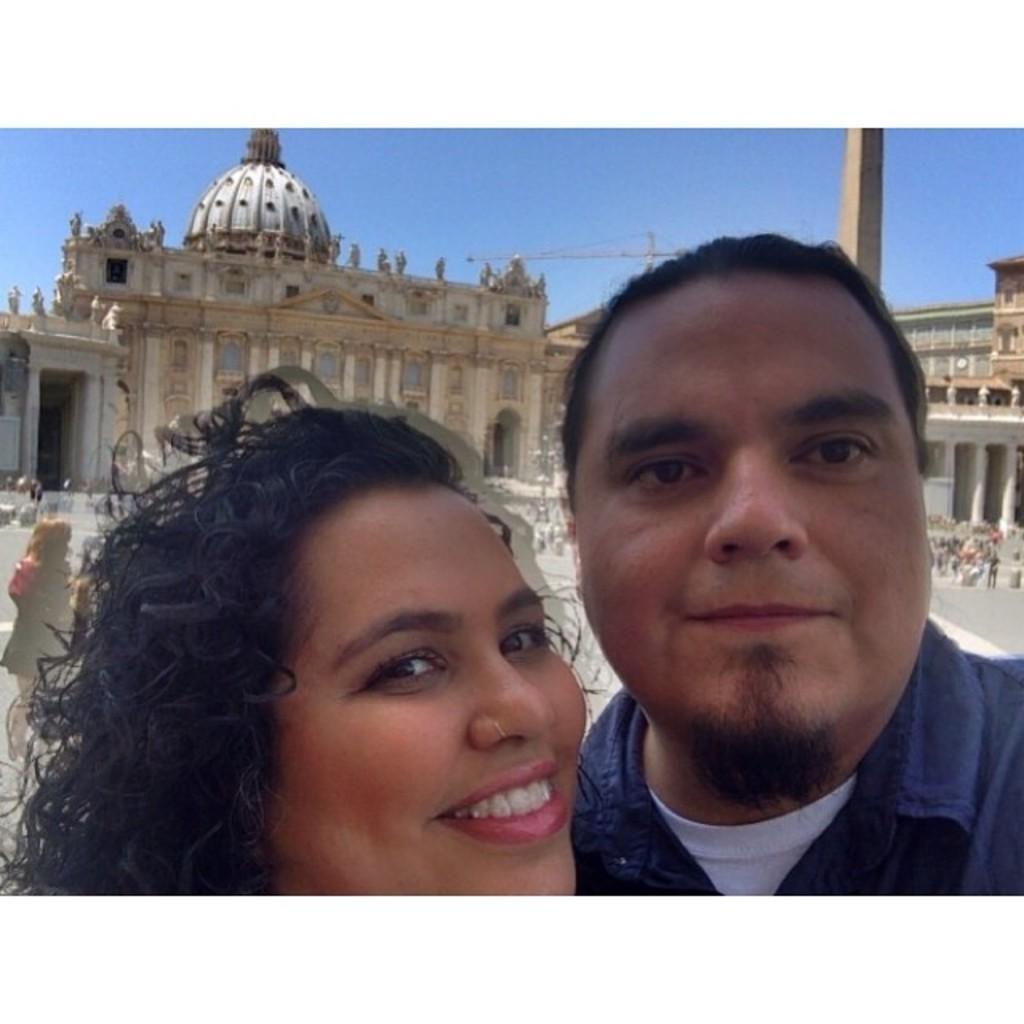Could you give a brief overview of what you see in this image? In the image two persons are standing and smiling. Behind them few people are standing and there are some buildings. At the top of the image there is sky. 